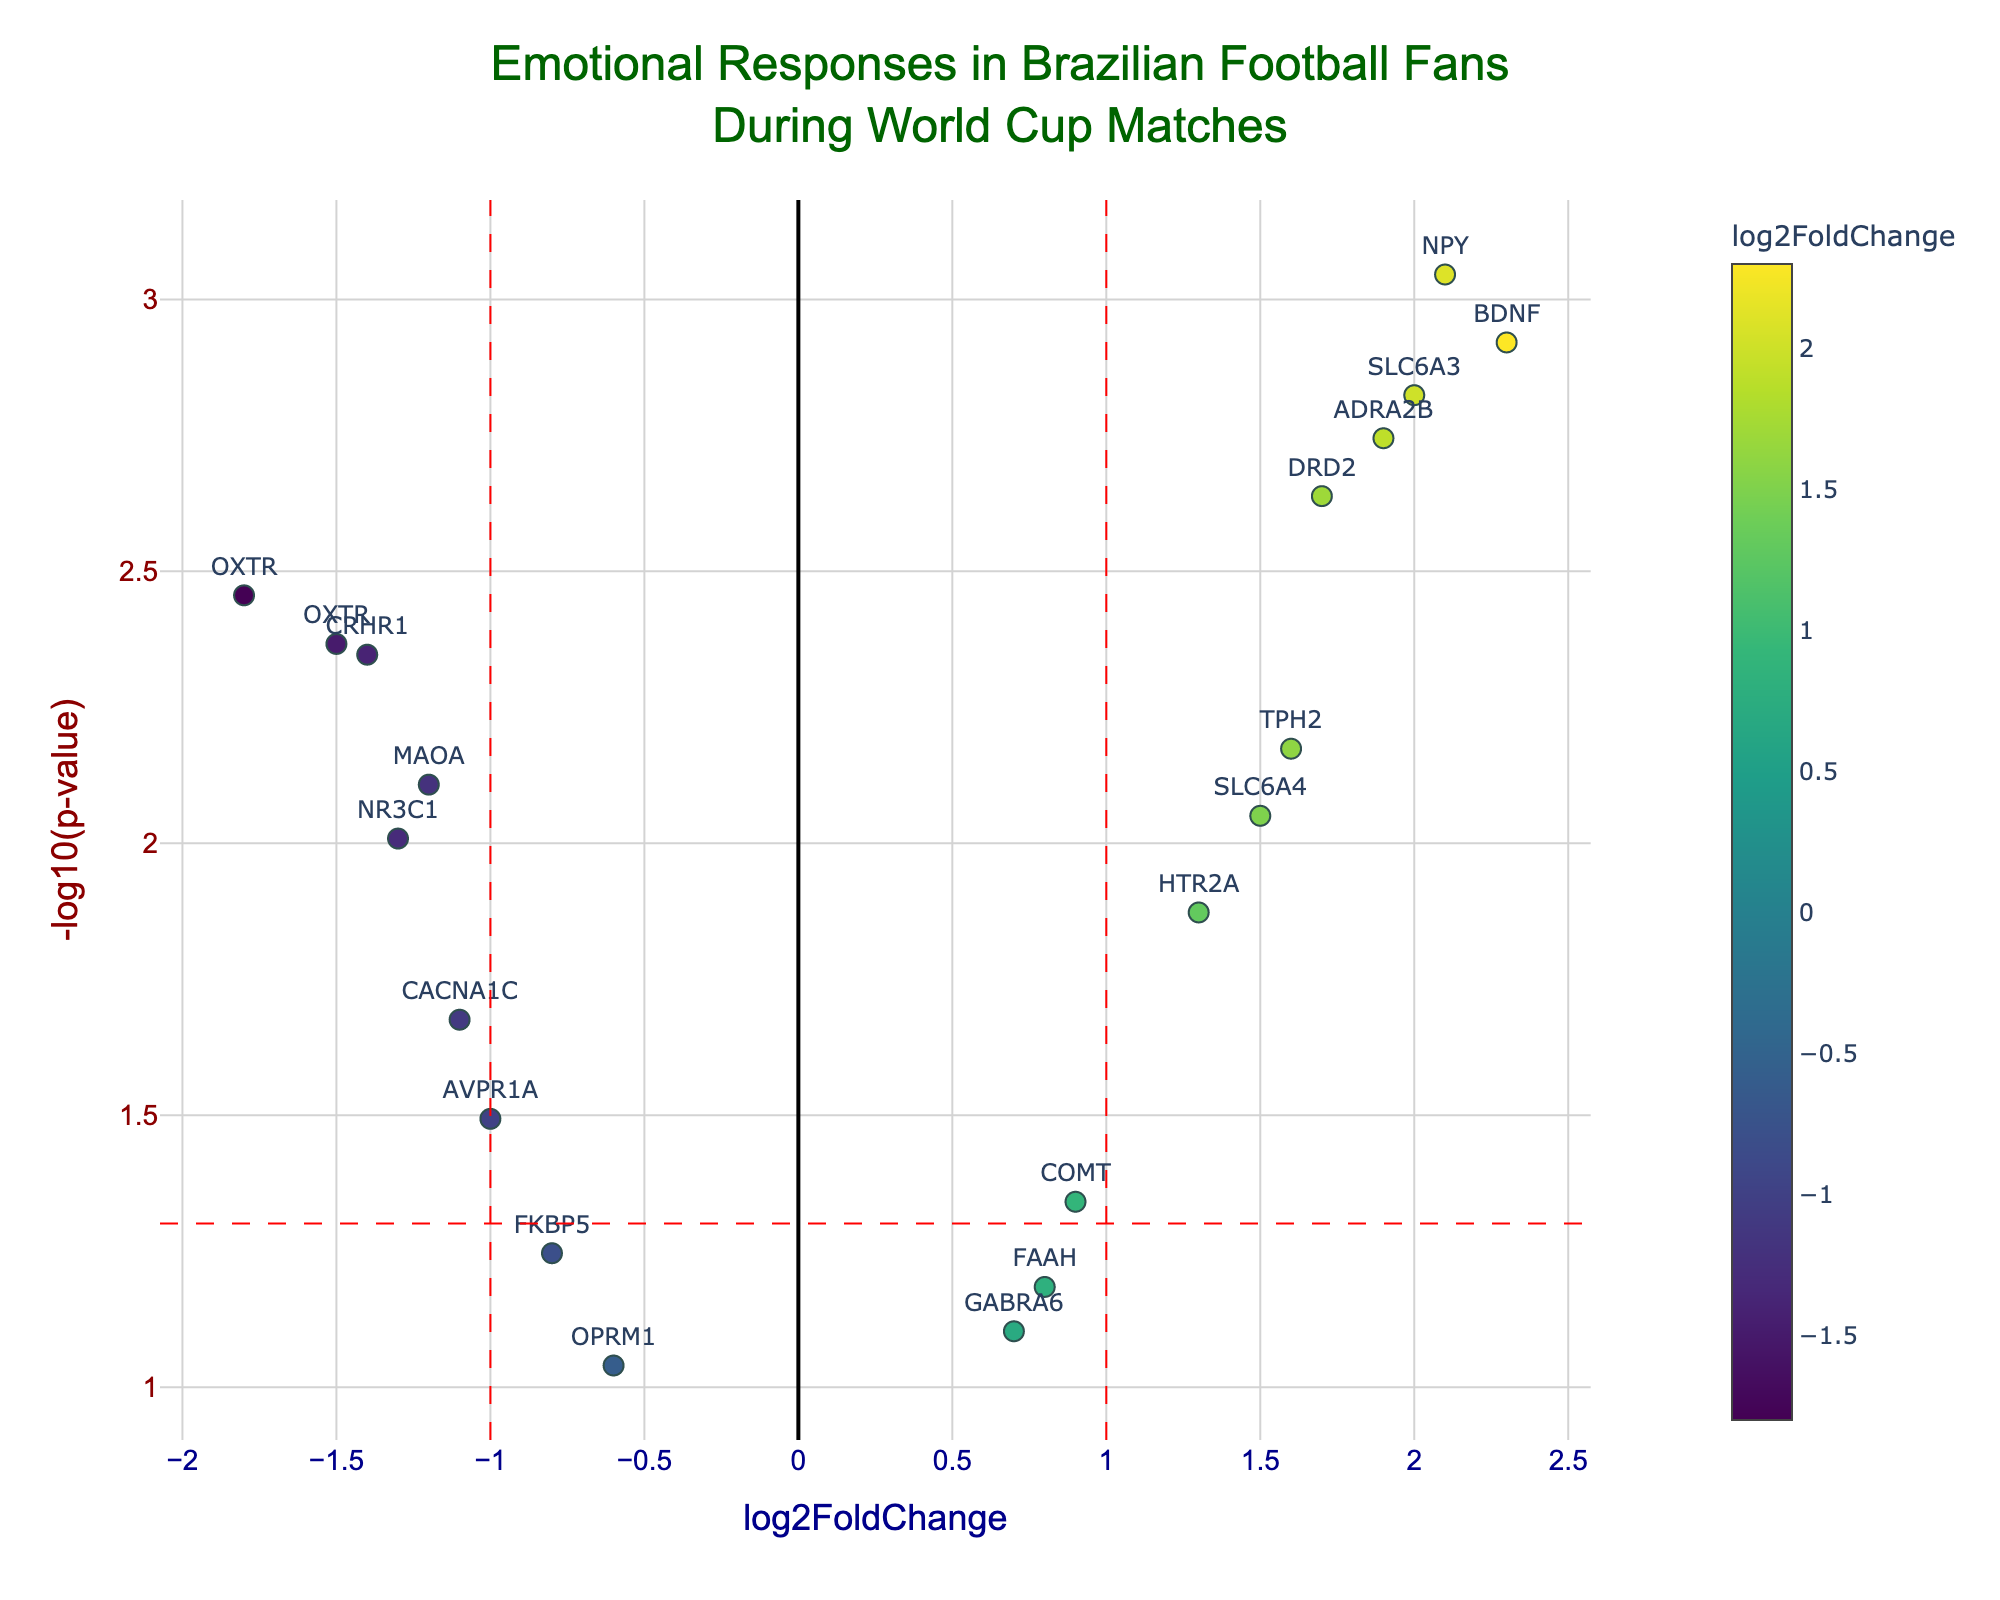How many genes have a p-value less than 0.01? To find the number of genes with a p-value less than 0.01, locate those points above the horizontal red dashed line marking -log10(0.01). Count the points above this threshold.
Answer: 12 Which gene has the highest log2FoldChange? Identify the gene with the highest x-axis value. This will be the point furthest to the right on the plot.
Answer: BDNF How many genes are significantly upregulated (log2FoldChange > 1 and p-value < 0.05)? Look for points with an x-axis value greater than 1 and a y-axis value above the horizontal red dashed line at -log10(0.05). Count these points.
Answer: 5 Which gene has the lowest p-value? Identify the gene with the highest y-axis value, as -log10(p-value) increases as p-value decreases.
Answer: NPY Are there more significantly downregulated genes (log2FoldChange < -1 and p-value < 0.05) or significantly upregulated genes (log2FoldChange > 1 and p-value < 0.05)? Compare the number of points to the left of the vertical red dashed line at -1 that are also above the horizontal red dashed line, with the number of points to the right of the vertical red dashed line at 1 that are above the horizontal red dashed line.
Answer: Upregulated Which gene with a negative log2FoldChange has the highest absolute FoldChange? For genes with a negative log2FoldChange, find the point with the furthest left x-axis value.
Answer: OXTR How many genes fall within the fold-change thresholds (between -1 and 1) but are significantly differentially expressed (p-value < 0.05)? Count the points with x-axis values between -1 and 1 and y-axis values above the horizontal red dashed line at -log10(0.05).
Answer: 4 